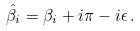Convert formula to latex. <formula><loc_0><loc_0><loc_500><loc_500>\hat { \beta } _ { i } = \beta _ { i } + i \pi - i \epsilon \, .</formula> 